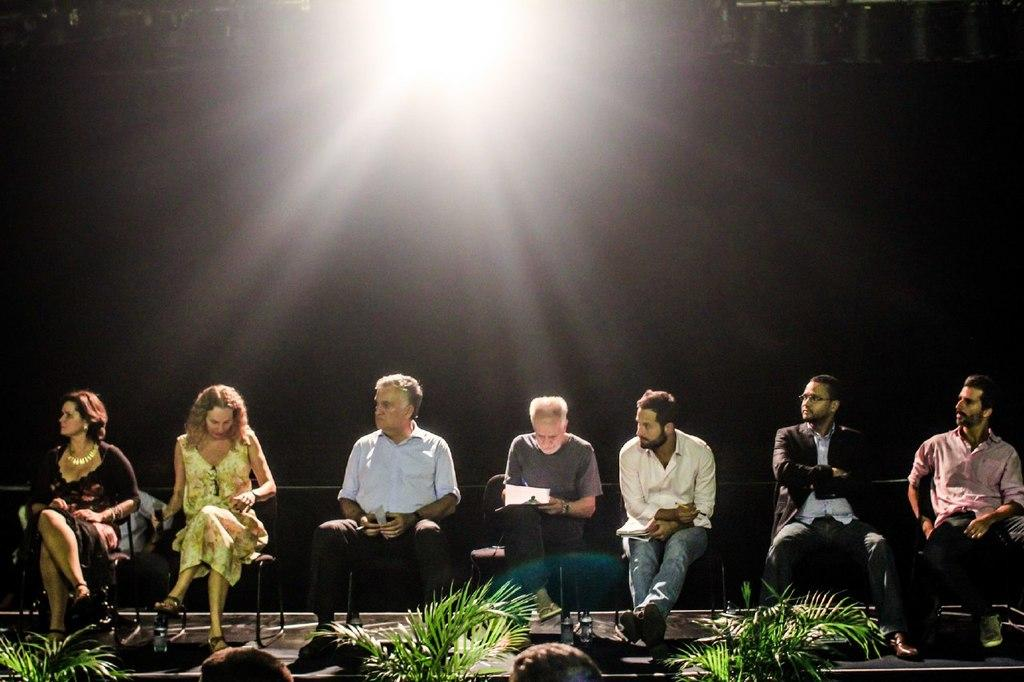What are the people in the image doing? The people in the image are sitting in chairs. What can be seen at the top of the image? There is a light at the top of the image. What is in front of the people sitting in chairs? There are plants in front of the people sitting in chairs. Can you describe the arrangement of the people and plants in the image? There are people between the plants. What type of stick can be seen holding up the flag in the image? There is no stick or flag present in the image. 